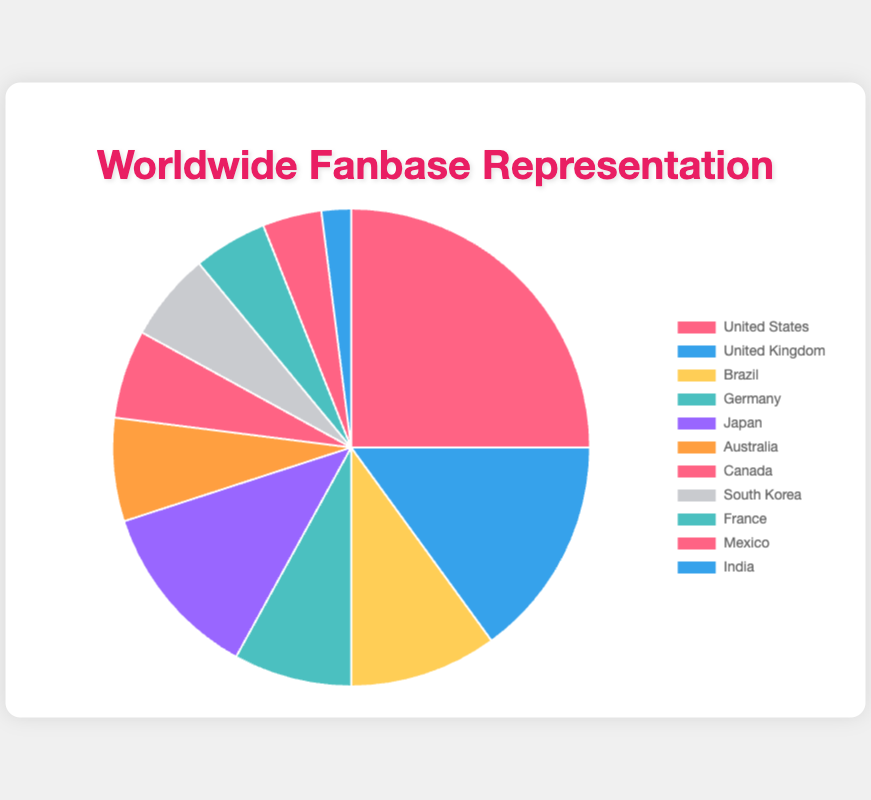What percentage of the fanbase does Japan represent? Look at the pie chart legend for Japan and match it with the respective slice in the pie chart. The legend indicates Japan represents 12% of the fanbase.
Answer: 12% Which two countries have the same percentage of the fanbase? Refer to the pie chart and look for two slices with the same percentage according to the legend descriptions. South Korea and Canada both have 6% representation.
Answer: South Korea and Canada What is the combined percentage of the fanbase for Brazil, Germany, and Japan? According to the pie chart, Brazil represents 10%, Germany represents 8%, and Japan represents 12%. Adding these together: 10% + 8% + 12% = 30%.
Answer: 30% Which country has the second largest fanbase representation? Look at the percentage values in the pie chart. The largest percentage is for the United States at 25%. The second largest is the United Kingdom at 15%.
Answer: United Kingdom How much smaller is the fanbase percentage for Australia compared to the United States? According to the pie chart, the United States represents 25% and Australia represents 7%. To find the difference: 25% - 7% = 18%.
Answer: 18% Which country has the least representation in the fanbase? By observing the pies for the smallest segment, the legend indicates that India represents the smallest portion with 2%.
Answer: India Among the total fanbase, what fraction does South Korea represent? According to the pie chart, South Korea has 6% of the fanbase. This representation in fraction form of the total 100% is 6/100 = 3/50.
Answer: 3/50 What is the total percentage of the fanbase for all the countries that have a representation of at least 10%? The countries with at least 10% are the United States (25%), United Kingdom (15%), Brazil (10%), and Japan (12%). Adding these together: 25% + 15% + 10% + 12% = 62%.
Answer: 62% Which country’s fanbase size is closest to that of France? France has a 5% representation. The closest percentages by looking at the pie chart slices are Canada and South Korea, each with 6%.
Answer: Canada and South Korea What is the difference in percentage between the countries with the highest and lowest fanbase representation? The United States has the highest fanbase percentage (25%), while India has the lowest (2%). The difference is 25% - 2% = 23%.
Answer: 23% 